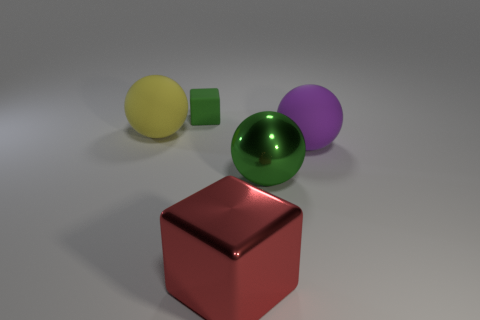Is there anything else that is the same size as the green matte block?
Provide a succinct answer. No. There is a large matte thing right of the green thing that is in front of the small matte object; what is its color?
Your answer should be compact. Purple. Is the number of tiny green matte things less than the number of large brown blocks?
Keep it short and to the point. No. Is there a tiny gray object made of the same material as the big green thing?
Keep it short and to the point. No. Does the tiny green object have the same shape as the shiny object that is on the right side of the large metal block?
Provide a succinct answer. No. Are there any big matte things behind the small cube?
Keep it short and to the point. No. What number of big green shiny objects have the same shape as the big yellow thing?
Provide a succinct answer. 1. Are the large block and the big object that is left of the tiny matte block made of the same material?
Make the answer very short. No. What number of large matte spheres are there?
Offer a terse response. 2. What size is the block that is in front of the large green shiny ball?
Provide a short and direct response. Large. 